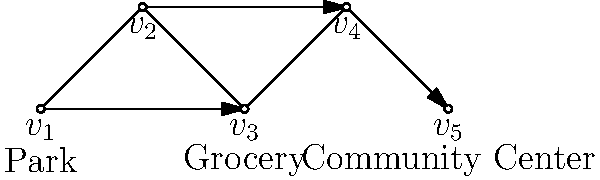In the given graph representing pedestrian paths in your neighborhood, what is the minimum number of edges that need to be traversed to reach the Community Center ($v_5$) from the Park ($v_1$)? To find the minimum number of edges needed to reach the Community Center ($v_5$) from the Park ($v_1$), we need to identify the shortest path between these two vertices. Let's analyze the possible paths:

1. Path 1: $v_1 \rightarrow v_2 \rightarrow v_3 \rightarrow v_4 \rightarrow v_5$
   This path traverses 4 edges.

2. Path 2: $v_1 \rightarrow v_3 \rightarrow v_4 \rightarrow v_5$
   This path traverses 3 edges.

Path 2 is shorter than Path 1, and there are no other possible paths that could be shorter. Therefore, the minimum number of edges that need to be traversed is 3.

This represents the most direct route for an elderly person to walk from the Park to the Community Center, passing by the Grocery store. It's important for city planners to consider such efficient pathways when designing pedestrian-friendly neighborhoods for the elderly.
Answer: 3 edges 